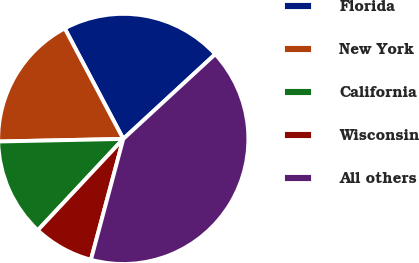Convert chart to OTSL. <chart><loc_0><loc_0><loc_500><loc_500><pie_chart><fcel>Florida<fcel>New York<fcel>California<fcel>Wisconsin<fcel>All others<nl><fcel>20.9%<fcel>17.58%<fcel>12.7%<fcel>7.81%<fcel>41.02%<nl></chart> 